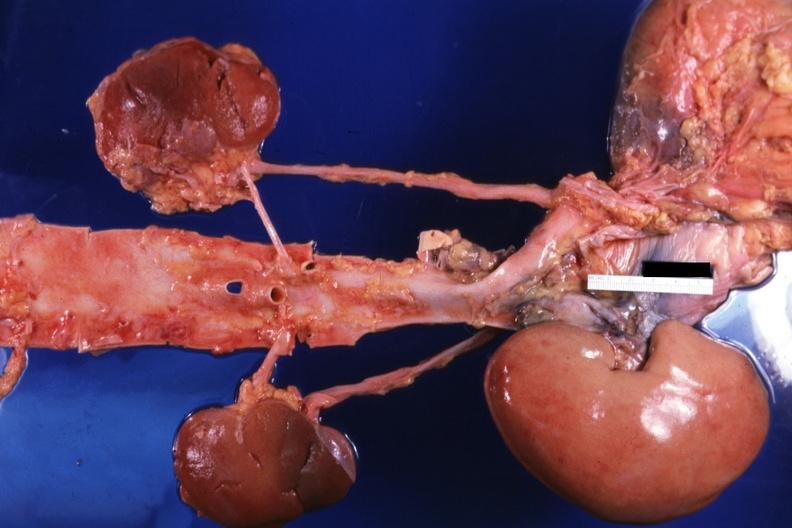what is placed relative to other structures?
Answer the question using a single word or phrase. The transplant 